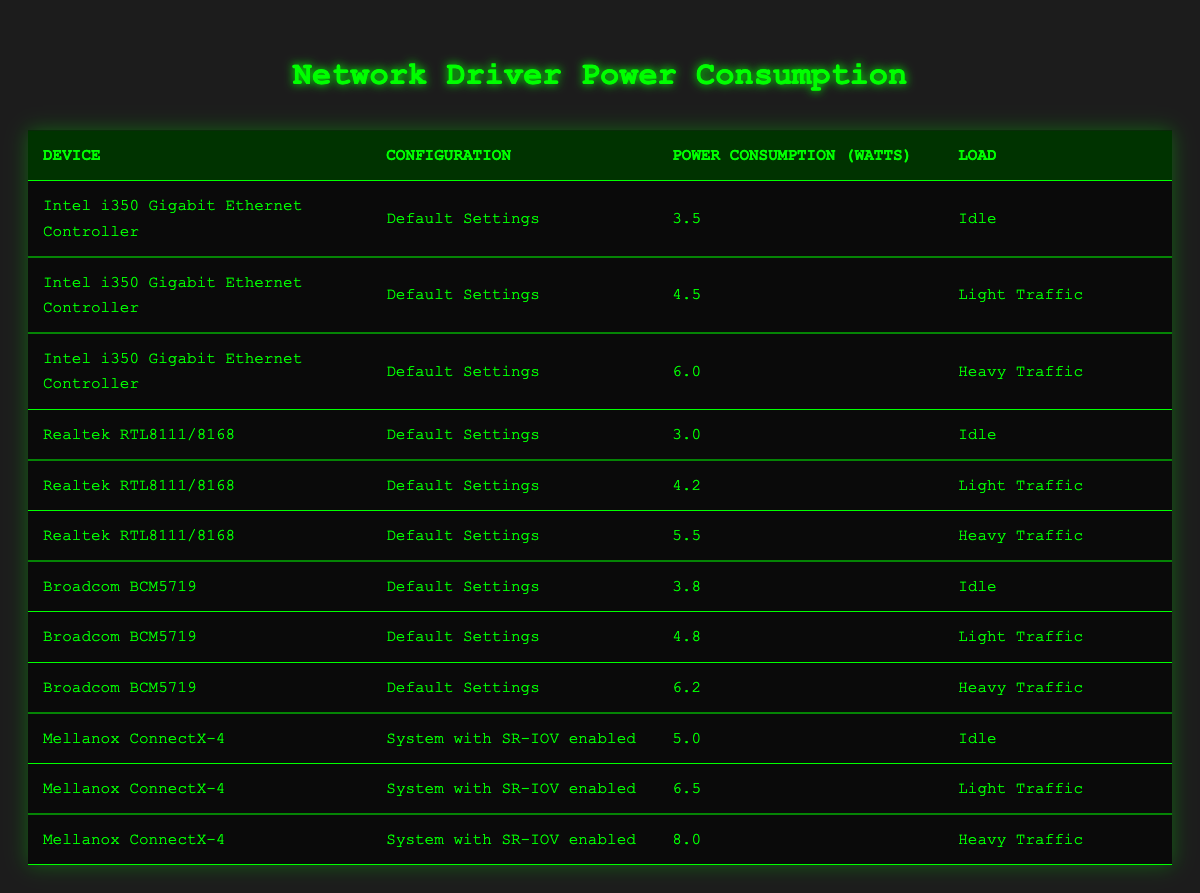What is the power consumption of the Intel i350 Gigabit Ethernet Controller under heavy traffic? The table shows that for the Intel i350 Gigabit Ethernet Controller under heavy traffic, the power consumption is 6.0 Watts. This can be found by locating the relevant row corresponding to this device and load situation.
Answer: 6.0 Watts Which device consumes the least power under idle conditions? By comparing the power consumption values for all devices listed under the idle load, the Realtek RTL8111/8168 has the lowest at 3.0 Watts. This is determined by checking each idle power consumption figure and identifying the minimum.
Answer: 3.0 Watts What is the average power consumption of the Broadcom BCM5719 across all load conditions? The power consumption values for the Broadcom BCM5719 are 3.8 Watts (Idle), 4.8 Watts (Light Traffic), and 6.2 Watts (Heavy Traffic). To find the average, we add these values (3.8 + 4.8 + 6.2 = 14.8) and divide by the number of entries (3), yielding an average of 14.8/3 = approximately 4.93 Watts.
Answer: 4.93 Watts True or False: The Mellanox ConnectX-4 consumes more power under heavy traffic than the Intel i350 Gigabit Ethernet Controller. The power consumption for Mellanox ConnectX-4 under heavy traffic is 8.0 Watts, while for Intel i350 under heavy traffic, it is 6.0 Watts. Since 8.0 is greater than 6.0, the statement is true.
Answer: True What is the difference in power consumption between the Realtek RTL8111/8168 under light traffic and the same device under heavy traffic? The Realtek RTL8111/8168's power consumption under light traffic is 4.2 Watts, and under heavy traffic is 5.5 Watts. To find the difference, subtract the light traffic value from the heavy traffic value (5.5 - 4.2 = 1.3 Watts).
Answer: 1.3 Watts How much more power does the Broadcom BCM5719 consume under heavy traffic compared to its idle state? The Broadcom BCM5719 consumes 6.2 Watts under heavy traffic and 3.8 Watts under idle conditions. The difference in power consumption is calculated as 6.2 - 3.8, resulting in a power increase of 2.4 Watts.
Answer: 2.4 Watts Which configuration has the highest power consumption for light traffic? The table indicates that the Mellanox ConnectX-4 with SR-IOV enabled has a power consumption of 6.5 Watts under light traffic, which is higher than the corresponding values for the other devices during the same load condition.
Answer: 6.5 Watts True or False: The power consumption of the Intel i350 Gigabit Ethernet Controller is the same for idle and light traffic. The table shows that the idle power consumption for the Intel i350 Gigabit Ethernet Controller is 3.5 Watts and for light traffic, it is 4.5 Watts. Since these values are different, the statement is false.
Answer: False 